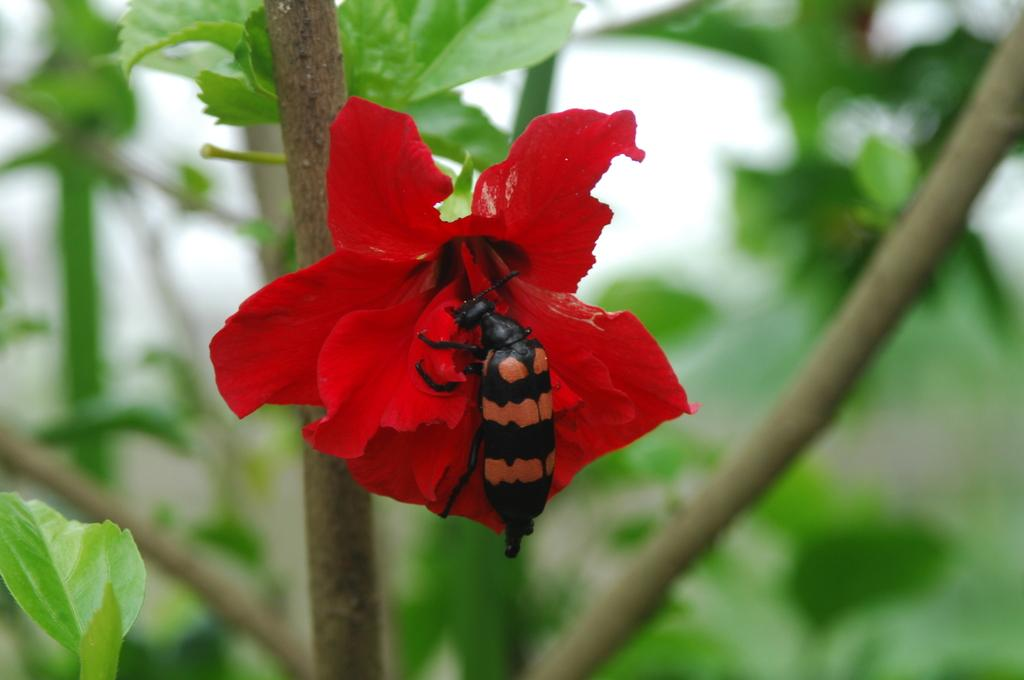What type of creature is present in the image? There is an insect in the image. What is the insect sitting on? The insect is on a red color hibiscus flower. Can you describe the background of the image? The background of the image is blurred. What type of dinner is the farmer having in the image? There is no farmer or dinner present in the image; it features an insect on a red hibiscus flower with a blurred background. 